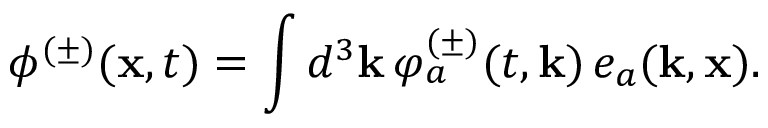<formula> <loc_0><loc_0><loc_500><loc_500>\phi ^ { ( \pm ) } ( { x } , t ) = \int d ^ { 3 } { k } \, \varphi _ { a } ^ { ( \pm ) } ( t , { k } ) \, e _ { a } ( { k } , { x } ) .</formula> 